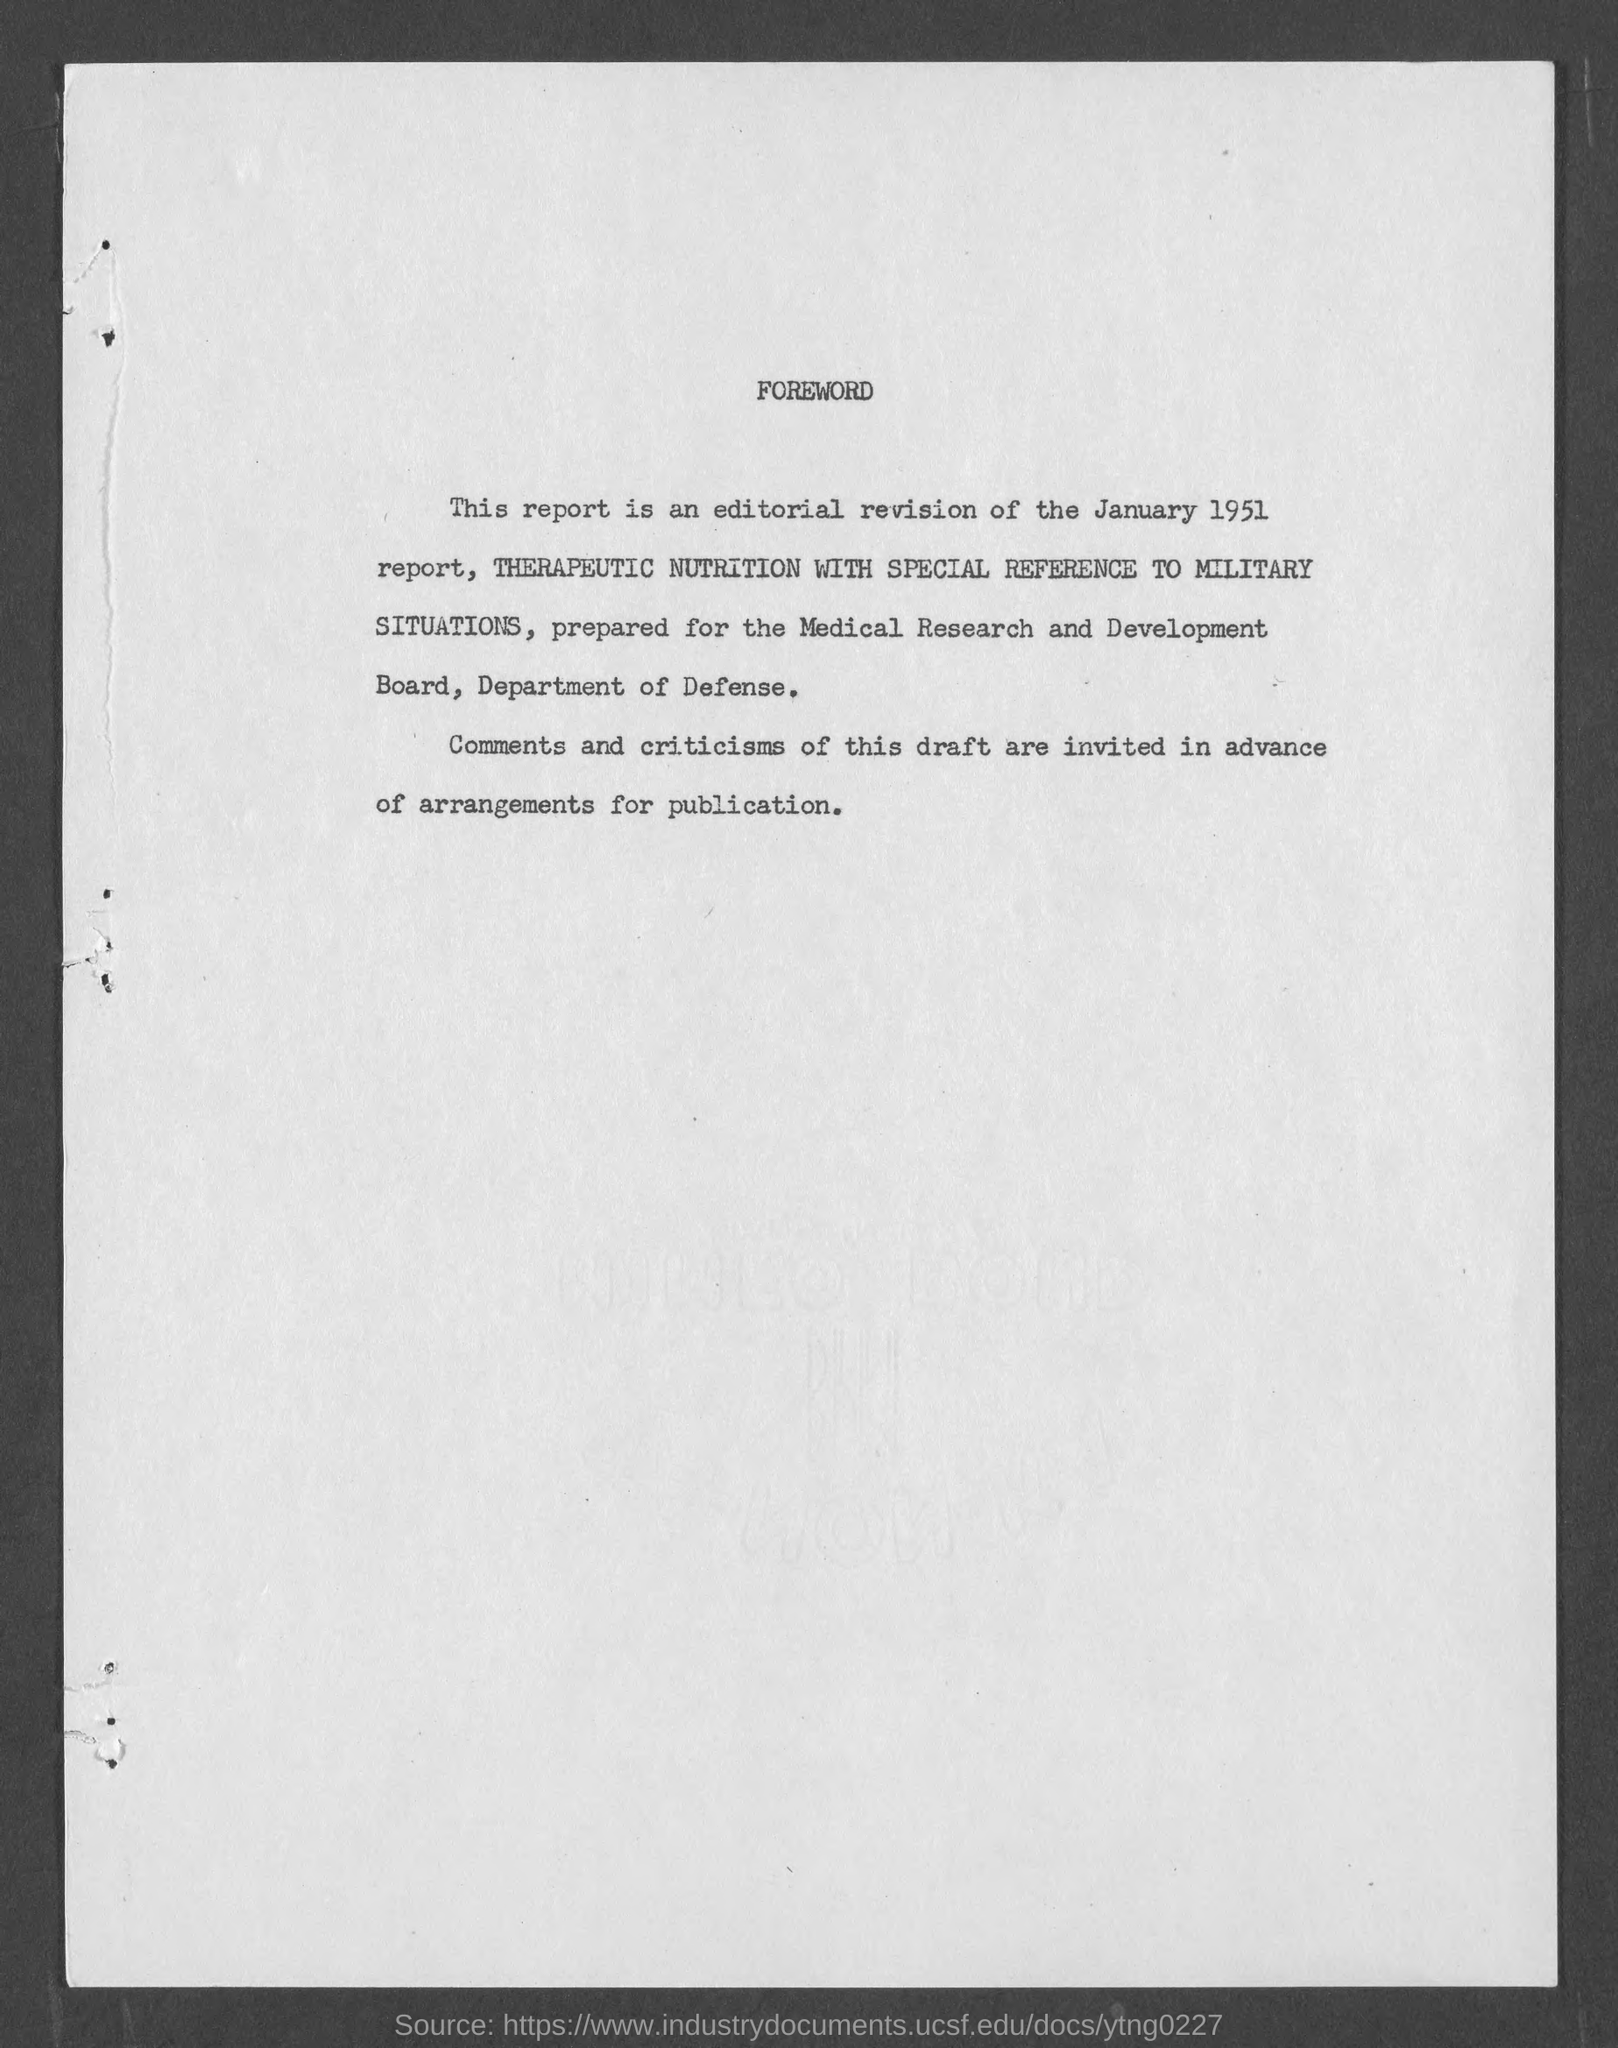Mention a couple of crucial points in this snapshot. This report was generated on January 1951. This report was prepared for the Medical Research and Development Board and the Department of Defense. 